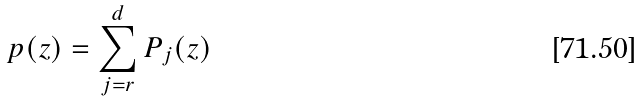Convert formula to latex. <formula><loc_0><loc_0><loc_500><loc_500>p ( z ) = \sum _ { j = r } ^ { d } P _ { j } ( z )</formula> 